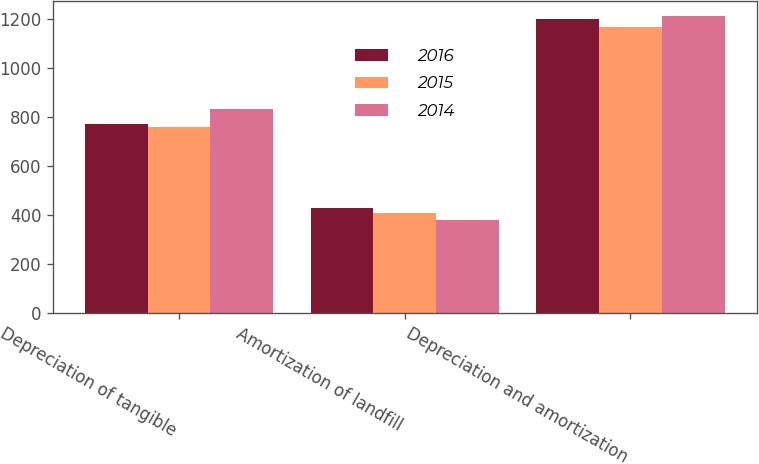<chart> <loc_0><loc_0><loc_500><loc_500><stacked_bar_chart><ecel><fcel>Depreciation of tangible<fcel>Amortization of landfill<fcel>Depreciation and amortization<nl><fcel>2016<fcel>773<fcel>428<fcel>1201<nl><fcel>2015<fcel>760<fcel>409<fcel>1169<nl><fcel>2014<fcel>834<fcel>380<fcel>1214<nl></chart> 